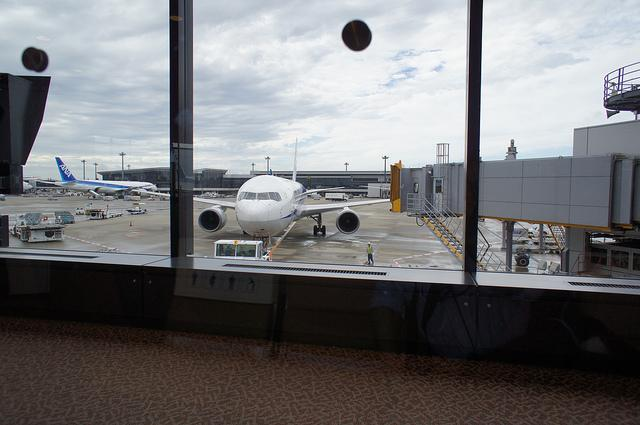Why does the man wear a yellow vest? Please explain your reasoning. visibility. So people can see him. 